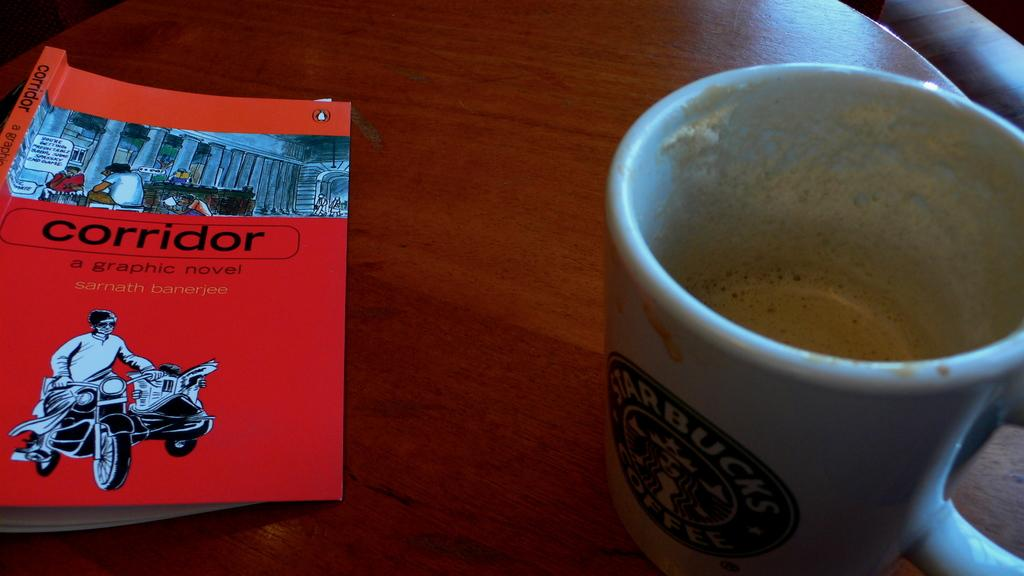<image>
Provide a brief description of the given image. A Starbucks coffee mug is on a table next to a graphic novel named corridor. 